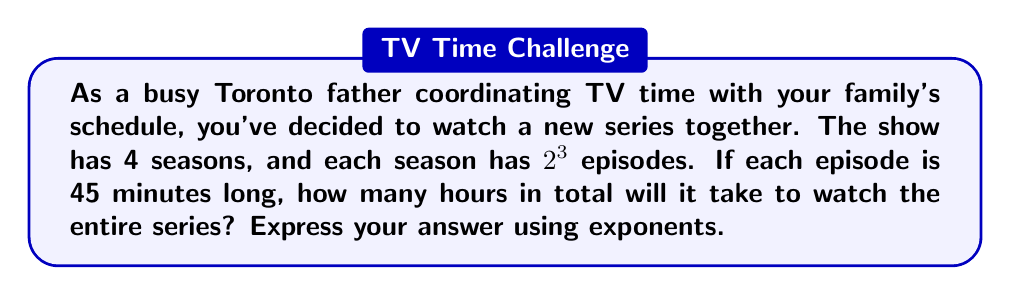Can you solve this math problem? Let's break this down step-by-step:

1) First, let's calculate the number of episodes per season:
   $2^3 = 2 \times 2 \times 2 = 8$ episodes per season

2) Now, we need to find the total number of episodes for all 4 seasons:
   $4 \times 2^3 = 2^2 \times 2^3 = 2^5 = 32$ total episodes

3) Each episode is 45 minutes long. To find the total number of minutes:
   $32 \times 45 = 2^5 \times (3 \times 3 \times 5) = 2^5 \times 3^2 \times 5 = 1440$ minutes

4) To convert minutes to hours, we divide by 60:
   $\frac{1440}{60} = \frac{2^5 \times 3^2 \times 5}{2^2 \times 3 \times 5} = 2^3 \times 3 = 24$ hours

5) We can express this final answer using exponents:
   $24 = 2^3 \times 3^1$
Answer: $2^3 \times 3^1$ hours 